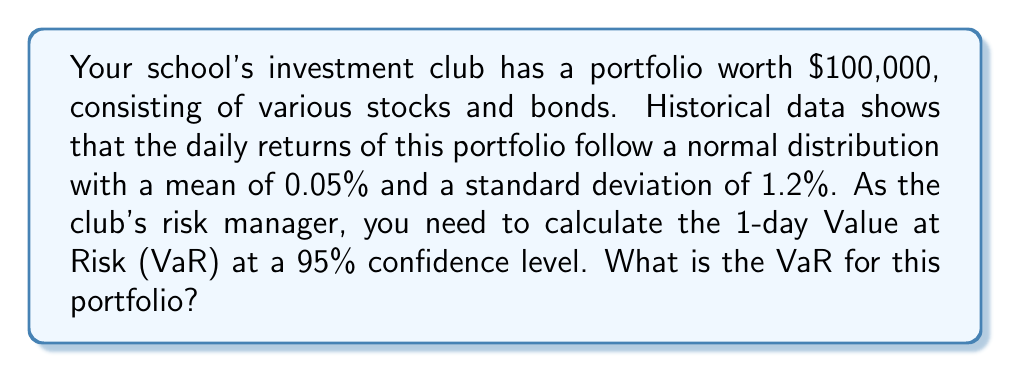Solve this math problem. To calculate the Value at Risk (VaR) for the given portfolio, we'll follow these steps:

1) First, recall that for a normal distribution, the z-score for a 95% confidence level is approximately 1.645 (this is the number of standard deviations from the mean in a normal distribution that encompasses 95% of the data).

2) The general formula for VaR is:

   $$VaR = P * (-\mu + z * \sigma)$$

   Where:
   $P$ is the portfolio value
   $\mu$ is the mean daily return
   $z$ is the z-score for the desired confidence level
   $\sigma$ is the standard deviation of daily returns

3) Let's plug in our values:

   $P = 100,000$
   $\mu = 0.05\% = 0.0005$
   $z = 1.645$ (for 95% confidence level)
   $\sigma = 1.2\% = 0.012$

4) Now we can calculate:

   $$VaR = 100,000 * (-0.0005 + 1.645 * 0.012)$$
   $$    = 100,000 * (0.019740)$$
   $$    = 1,974$$

5) Therefore, the 1-day VaR at 95% confidence level is $1,974.

This means that there is a 5% chance that the portfolio will lose more than $1,974 in a single day, based on the historical data and assuming normal distribution of returns.
Answer: The 1-day Value at Risk (VaR) at a 95% confidence level for the portfolio is $1,974. 